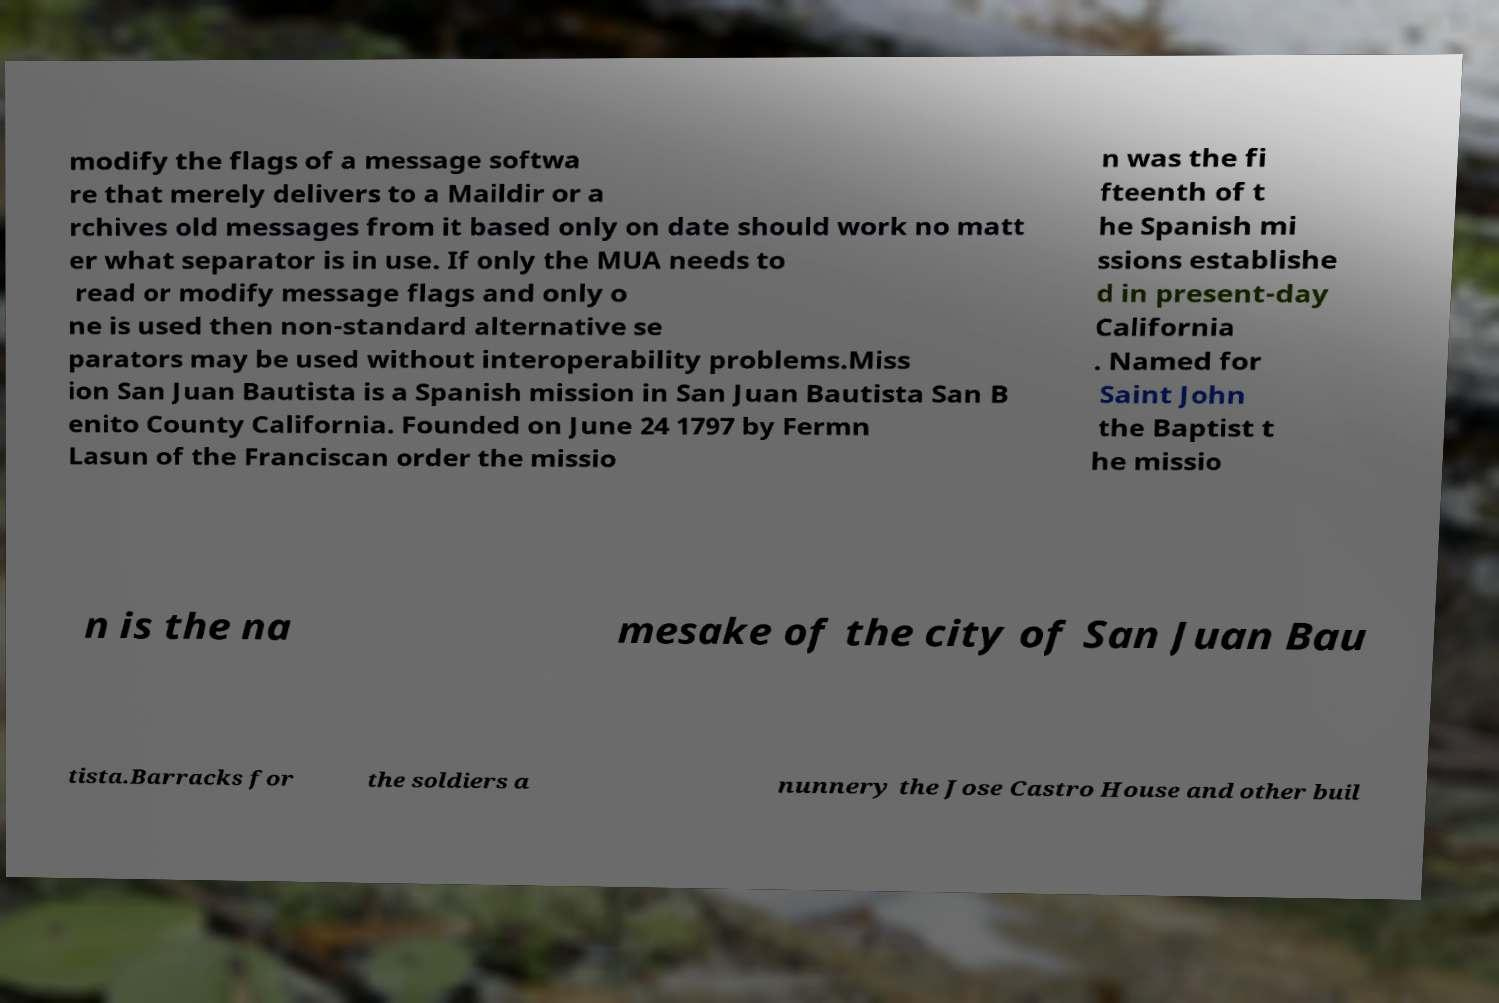What messages or text are displayed in this image? I need them in a readable, typed format. modify the flags of a message softwa re that merely delivers to a Maildir or a rchives old messages from it based only on date should work no matt er what separator is in use. If only the MUA needs to read or modify message flags and only o ne is used then non-standard alternative se parators may be used without interoperability problems.Miss ion San Juan Bautista is a Spanish mission in San Juan Bautista San B enito County California. Founded on June 24 1797 by Fermn Lasun of the Franciscan order the missio n was the fi fteenth of t he Spanish mi ssions establishe d in present-day California . Named for Saint John the Baptist t he missio n is the na mesake of the city of San Juan Bau tista.Barracks for the soldiers a nunnery the Jose Castro House and other buil 